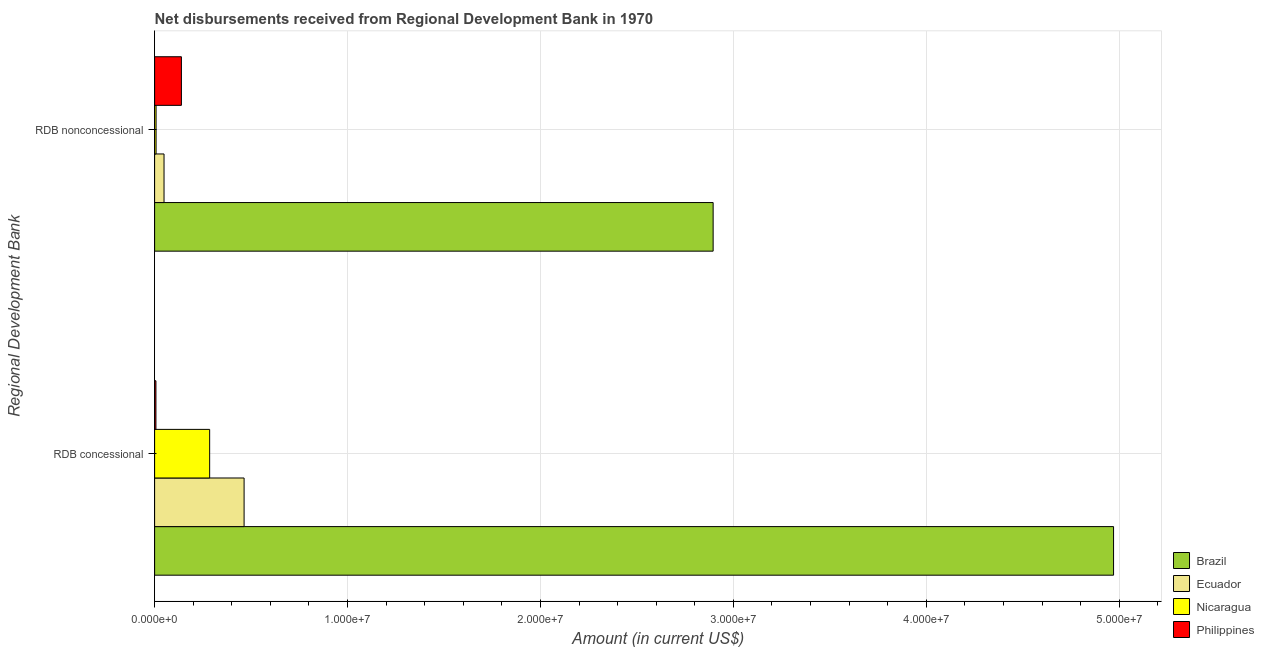How many groups of bars are there?
Offer a terse response. 2. How many bars are there on the 1st tick from the top?
Keep it short and to the point. 4. How many bars are there on the 2nd tick from the bottom?
Your answer should be very brief. 4. What is the label of the 2nd group of bars from the top?
Offer a very short reply. RDB concessional. What is the net concessional disbursements from rdb in Brazil?
Provide a succinct answer. 4.97e+07. Across all countries, what is the maximum net non concessional disbursements from rdb?
Make the answer very short. 2.90e+07. Across all countries, what is the minimum net concessional disbursements from rdb?
Make the answer very short. 6.90e+04. What is the total net concessional disbursements from rdb in the graph?
Offer a very short reply. 5.73e+07. What is the difference between the net non concessional disbursements from rdb in Nicaragua and that in Ecuador?
Provide a short and direct response. -4.13e+05. What is the difference between the net non concessional disbursements from rdb in Ecuador and the net concessional disbursements from rdb in Nicaragua?
Your answer should be very brief. -2.36e+06. What is the average net concessional disbursements from rdb per country?
Your response must be concise. 1.43e+07. What is the difference between the net concessional disbursements from rdb and net non concessional disbursements from rdb in Brazil?
Your answer should be compact. 2.08e+07. In how many countries, is the net non concessional disbursements from rdb greater than 38000000 US$?
Offer a terse response. 0. What is the ratio of the net non concessional disbursements from rdb in Ecuador to that in Nicaragua?
Your answer should be very brief. 6.43. In how many countries, is the net non concessional disbursements from rdb greater than the average net non concessional disbursements from rdb taken over all countries?
Your response must be concise. 1. What does the 1st bar from the top in RDB concessional represents?
Offer a terse response. Philippines. How many bars are there?
Give a very brief answer. 8. Are all the bars in the graph horizontal?
Give a very brief answer. Yes. How many countries are there in the graph?
Give a very brief answer. 4. What is the difference between two consecutive major ticks on the X-axis?
Offer a very short reply. 1.00e+07. Are the values on the major ticks of X-axis written in scientific E-notation?
Give a very brief answer. Yes. Does the graph contain any zero values?
Provide a succinct answer. No. How many legend labels are there?
Your response must be concise. 4. How are the legend labels stacked?
Ensure brevity in your answer.  Vertical. What is the title of the graph?
Offer a terse response. Net disbursements received from Regional Development Bank in 1970. Does "Aruba" appear as one of the legend labels in the graph?
Provide a succinct answer. No. What is the label or title of the X-axis?
Provide a succinct answer. Amount (in current US$). What is the label or title of the Y-axis?
Your answer should be compact. Regional Development Bank. What is the Amount (in current US$) in Brazil in RDB concessional?
Give a very brief answer. 4.97e+07. What is the Amount (in current US$) in Ecuador in RDB concessional?
Your response must be concise. 4.64e+06. What is the Amount (in current US$) of Nicaragua in RDB concessional?
Your response must be concise. 2.85e+06. What is the Amount (in current US$) of Philippines in RDB concessional?
Keep it short and to the point. 6.90e+04. What is the Amount (in current US$) in Brazil in RDB nonconcessional?
Keep it short and to the point. 2.90e+07. What is the Amount (in current US$) of Ecuador in RDB nonconcessional?
Your response must be concise. 4.89e+05. What is the Amount (in current US$) in Nicaragua in RDB nonconcessional?
Your answer should be very brief. 7.60e+04. What is the Amount (in current US$) of Philippines in RDB nonconcessional?
Offer a very short reply. 1.39e+06. Across all Regional Development Bank, what is the maximum Amount (in current US$) of Brazil?
Your answer should be very brief. 4.97e+07. Across all Regional Development Bank, what is the maximum Amount (in current US$) of Ecuador?
Give a very brief answer. 4.64e+06. Across all Regional Development Bank, what is the maximum Amount (in current US$) of Nicaragua?
Ensure brevity in your answer.  2.85e+06. Across all Regional Development Bank, what is the maximum Amount (in current US$) in Philippines?
Ensure brevity in your answer.  1.39e+06. Across all Regional Development Bank, what is the minimum Amount (in current US$) in Brazil?
Make the answer very short. 2.90e+07. Across all Regional Development Bank, what is the minimum Amount (in current US$) of Ecuador?
Your response must be concise. 4.89e+05. Across all Regional Development Bank, what is the minimum Amount (in current US$) of Nicaragua?
Keep it short and to the point. 7.60e+04. Across all Regional Development Bank, what is the minimum Amount (in current US$) in Philippines?
Ensure brevity in your answer.  6.90e+04. What is the total Amount (in current US$) in Brazil in the graph?
Make the answer very short. 7.87e+07. What is the total Amount (in current US$) of Ecuador in the graph?
Offer a very short reply. 5.13e+06. What is the total Amount (in current US$) of Nicaragua in the graph?
Offer a terse response. 2.93e+06. What is the total Amount (in current US$) in Philippines in the graph?
Your answer should be compact. 1.46e+06. What is the difference between the Amount (in current US$) of Brazil in RDB concessional and that in RDB nonconcessional?
Ensure brevity in your answer.  2.08e+07. What is the difference between the Amount (in current US$) of Ecuador in RDB concessional and that in RDB nonconcessional?
Ensure brevity in your answer.  4.15e+06. What is the difference between the Amount (in current US$) of Nicaragua in RDB concessional and that in RDB nonconcessional?
Your answer should be very brief. 2.78e+06. What is the difference between the Amount (in current US$) of Philippines in RDB concessional and that in RDB nonconcessional?
Your response must be concise. -1.32e+06. What is the difference between the Amount (in current US$) in Brazil in RDB concessional and the Amount (in current US$) in Ecuador in RDB nonconcessional?
Give a very brief answer. 4.92e+07. What is the difference between the Amount (in current US$) in Brazil in RDB concessional and the Amount (in current US$) in Nicaragua in RDB nonconcessional?
Keep it short and to the point. 4.96e+07. What is the difference between the Amount (in current US$) of Brazil in RDB concessional and the Amount (in current US$) of Philippines in RDB nonconcessional?
Keep it short and to the point. 4.83e+07. What is the difference between the Amount (in current US$) in Ecuador in RDB concessional and the Amount (in current US$) in Nicaragua in RDB nonconcessional?
Your answer should be compact. 4.56e+06. What is the difference between the Amount (in current US$) in Ecuador in RDB concessional and the Amount (in current US$) in Philippines in RDB nonconcessional?
Offer a very short reply. 3.25e+06. What is the difference between the Amount (in current US$) of Nicaragua in RDB concessional and the Amount (in current US$) of Philippines in RDB nonconcessional?
Offer a very short reply. 1.46e+06. What is the average Amount (in current US$) of Brazil per Regional Development Bank?
Offer a terse response. 3.93e+07. What is the average Amount (in current US$) of Ecuador per Regional Development Bank?
Offer a very short reply. 2.56e+06. What is the average Amount (in current US$) of Nicaragua per Regional Development Bank?
Your response must be concise. 1.46e+06. What is the average Amount (in current US$) of Philippines per Regional Development Bank?
Offer a very short reply. 7.29e+05. What is the difference between the Amount (in current US$) of Brazil and Amount (in current US$) of Ecuador in RDB concessional?
Your answer should be compact. 4.51e+07. What is the difference between the Amount (in current US$) in Brazil and Amount (in current US$) in Nicaragua in RDB concessional?
Your response must be concise. 4.69e+07. What is the difference between the Amount (in current US$) of Brazil and Amount (in current US$) of Philippines in RDB concessional?
Your answer should be very brief. 4.96e+07. What is the difference between the Amount (in current US$) of Ecuador and Amount (in current US$) of Nicaragua in RDB concessional?
Offer a terse response. 1.78e+06. What is the difference between the Amount (in current US$) in Ecuador and Amount (in current US$) in Philippines in RDB concessional?
Offer a terse response. 4.57e+06. What is the difference between the Amount (in current US$) in Nicaragua and Amount (in current US$) in Philippines in RDB concessional?
Your answer should be compact. 2.78e+06. What is the difference between the Amount (in current US$) of Brazil and Amount (in current US$) of Ecuador in RDB nonconcessional?
Give a very brief answer. 2.85e+07. What is the difference between the Amount (in current US$) in Brazil and Amount (in current US$) in Nicaragua in RDB nonconcessional?
Offer a very short reply. 2.89e+07. What is the difference between the Amount (in current US$) in Brazil and Amount (in current US$) in Philippines in RDB nonconcessional?
Provide a succinct answer. 2.76e+07. What is the difference between the Amount (in current US$) of Ecuador and Amount (in current US$) of Nicaragua in RDB nonconcessional?
Keep it short and to the point. 4.13e+05. What is the difference between the Amount (in current US$) of Ecuador and Amount (in current US$) of Philippines in RDB nonconcessional?
Provide a succinct answer. -9.00e+05. What is the difference between the Amount (in current US$) of Nicaragua and Amount (in current US$) of Philippines in RDB nonconcessional?
Provide a short and direct response. -1.31e+06. What is the ratio of the Amount (in current US$) of Brazil in RDB concessional to that in RDB nonconcessional?
Make the answer very short. 1.72. What is the ratio of the Amount (in current US$) in Ecuador in RDB concessional to that in RDB nonconcessional?
Your answer should be very brief. 9.49. What is the ratio of the Amount (in current US$) of Nicaragua in RDB concessional to that in RDB nonconcessional?
Provide a short and direct response. 37.55. What is the ratio of the Amount (in current US$) in Philippines in RDB concessional to that in RDB nonconcessional?
Provide a short and direct response. 0.05. What is the difference between the highest and the second highest Amount (in current US$) of Brazil?
Give a very brief answer. 2.08e+07. What is the difference between the highest and the second highest Amount (in current US$) of Ecuador?
Keep it short and to the point. 4.15e+06. What is the difference between the highest and the second highest Amount (in current US$) in Nicaragua?
Keep it short and to the point. 2.78e+06. What is the difference between the highest and the second highest Amount (in current US$) in Philippines?
Provide a short and direct response. 1.32e+06. What is the difference between the highest and the lowest Amount (in current US$) of Brazil?
Offer a terse response. 2.08e+07. What is the difference between the highest and the lowest Amount (in current US$) of Ecuador?
Offer a very short reply. 4.15e+06. What is the difference between the highest and the lowest Amount (in current US$) in Nicaragua?
Offer a terse response. 2.78e+06. What is the difference between the highest and the lowest Amount (in current US$) of Philippines?
Keep it short and to the point. 1.32e+06. 